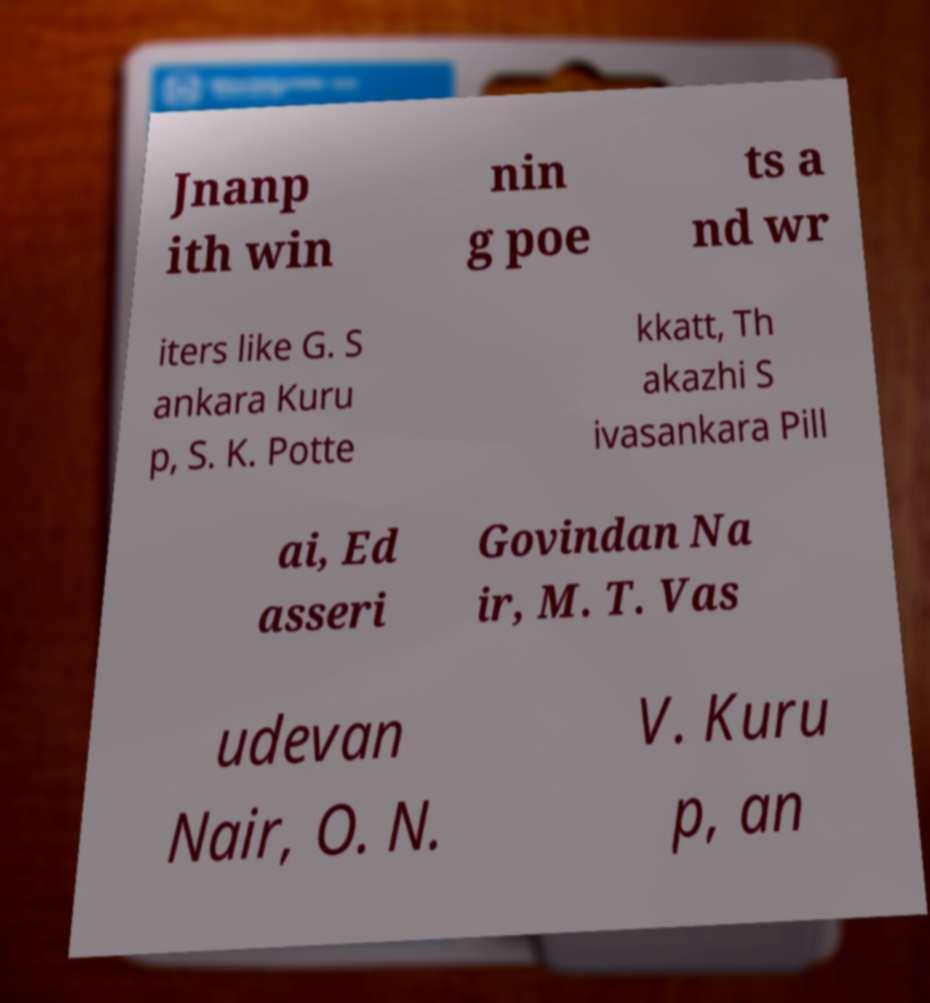Could you assist in decoding the text presented in this image and type it out clearly? Jnanp ith win nin g poe ts a nd wr iters like G. S ankara Kuru p, S. K. Potte kkatt, Th akazhi S ivasankara Pill ai, Ed asseri Govindan Na ir, M. T. Vas udevan Nair, O. N. V. Kuru p, an 